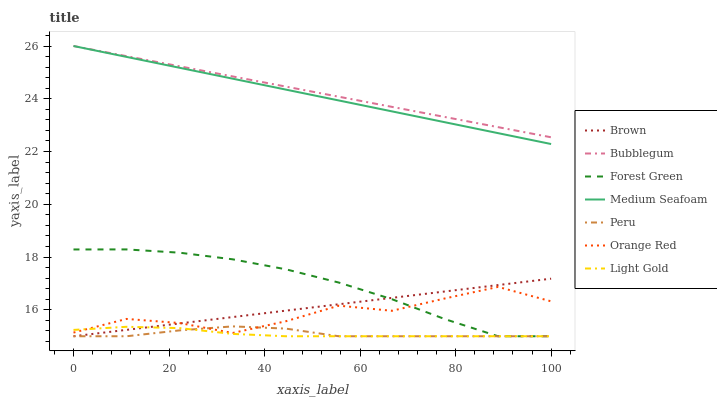Does Light Gold have the minimum area under the curve?
Answer yes or no. Yes. Does Bubblegum have the maximum area under the curve?
Answer yes or no. Yes. Does Orange Red have the minimum area under the curve?
Answer yes or no. No. Does Orange Red have the maximum area under the curve?
Answer yes or no. No. Is Medium Seafoam the smoothest?
Answer yes or no. Yes. Is Orange Red the roughest?
Answer yes or no. Yes. Is Bubblegum the smoothest?
Answer yes or no. No. Is Bubblegum the roughest?
Answer yes or no. No. Does Brown have the lowest value?
Answer yes or no. Yes. Does Orange Red have the lowest value?
Answer yes or no. No. Does Medium Seafoam have the highest value?
Answer yes or no. Yes. Does Orange Red have the highest value?
Answer yes or no. No. Is Forest Green less than Bubblegum?
Answer yes or no. Yes. Is Medium Seafoam greater than Brown?
Answer yes or no. Yes. Does Medium Seafoam intersect Bubblegum?
Answer yes or no. Yes. Is Medium Seafoam less than Bubblegum?
Answer yes or no. No. Is Medium Seafoam greater than Bubblegum?
Answer yes or no. No. Does Forest Green intersect Bubblegum?
Answer yes or no. No. 